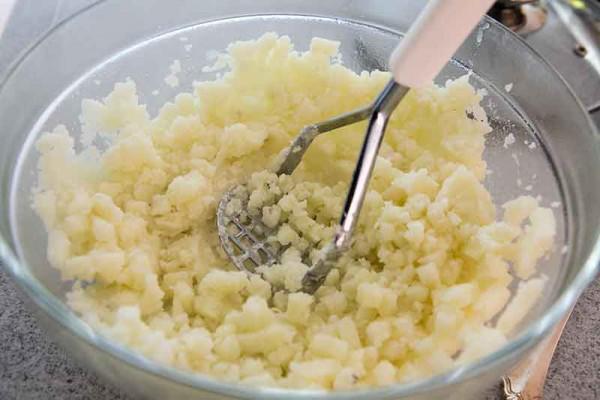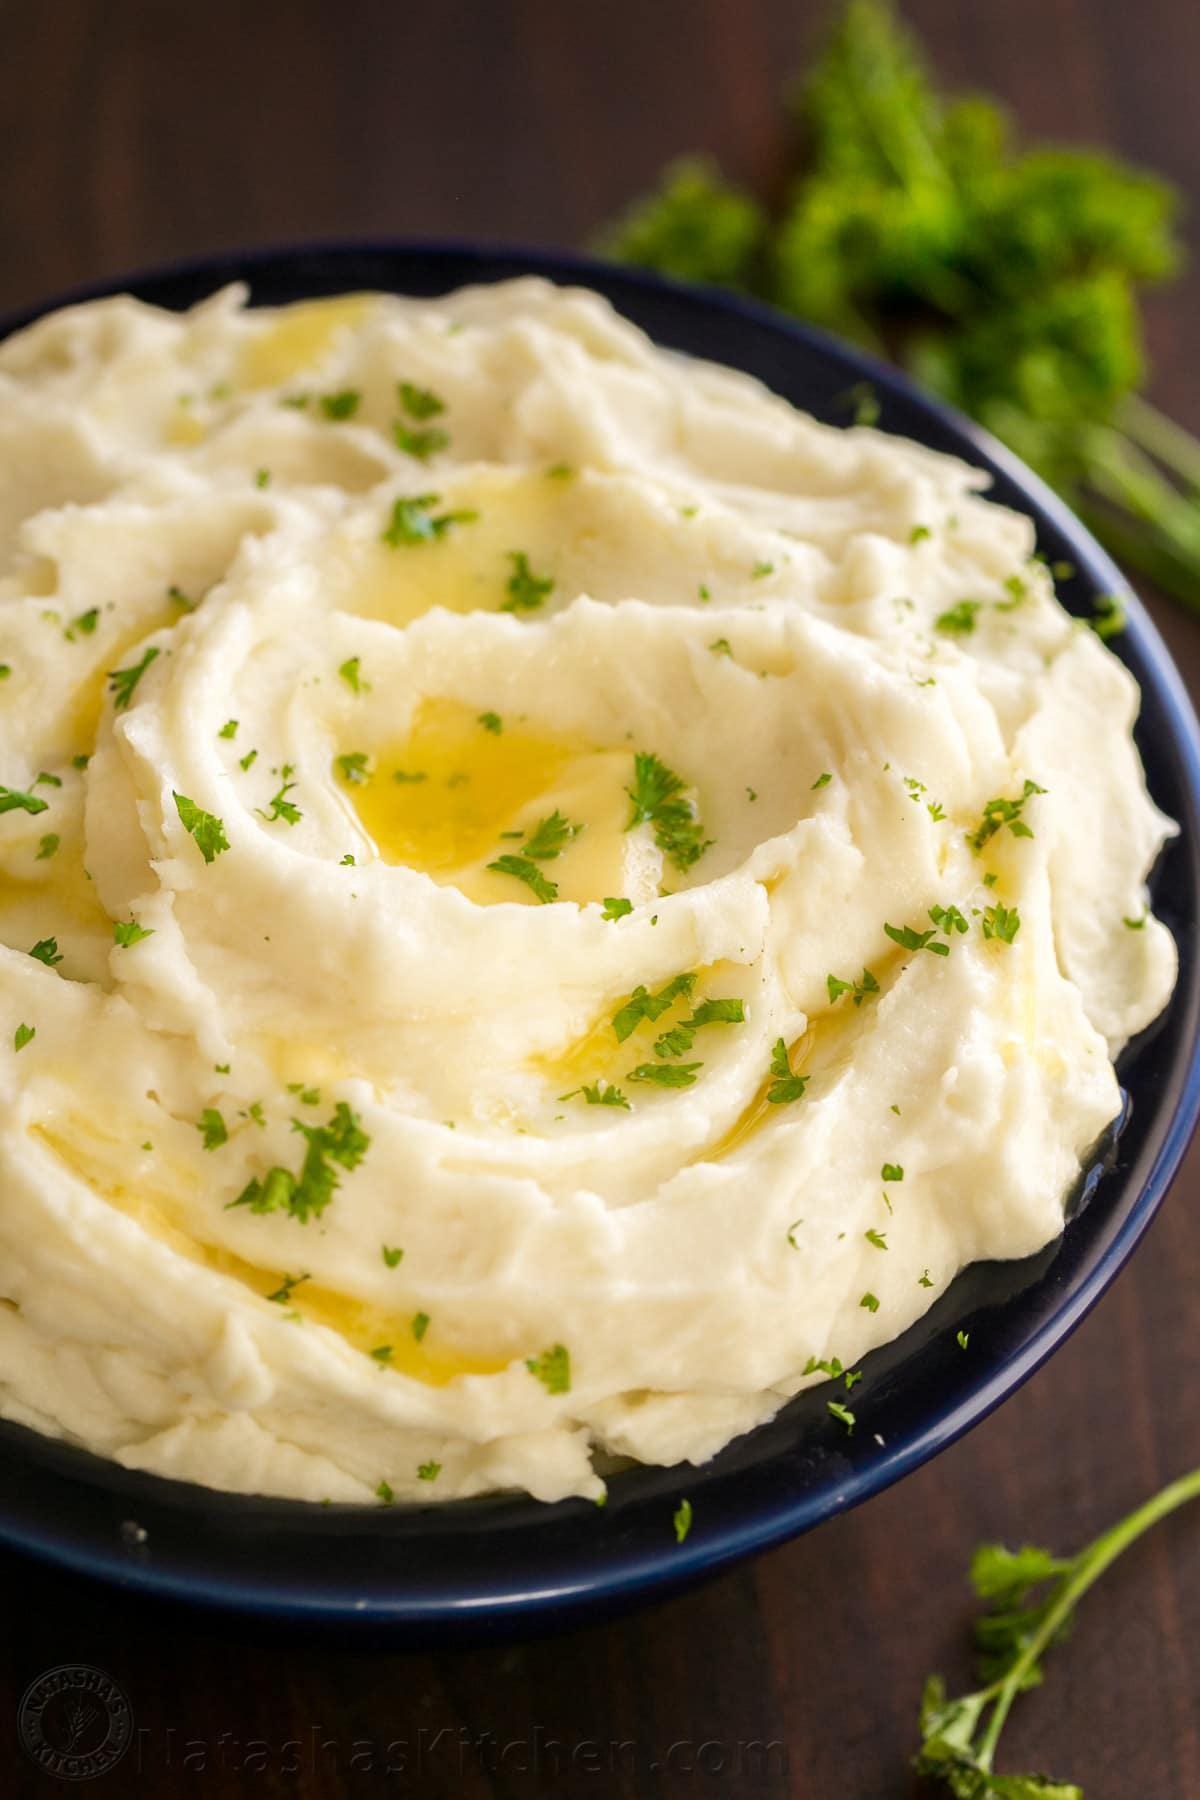The first image is the image on the left, the second image is the image on the right. Assess this claim about the two images: "herbs are sprinkled over the mashed potato". Correct or not? Answer yes or no. Yes. 